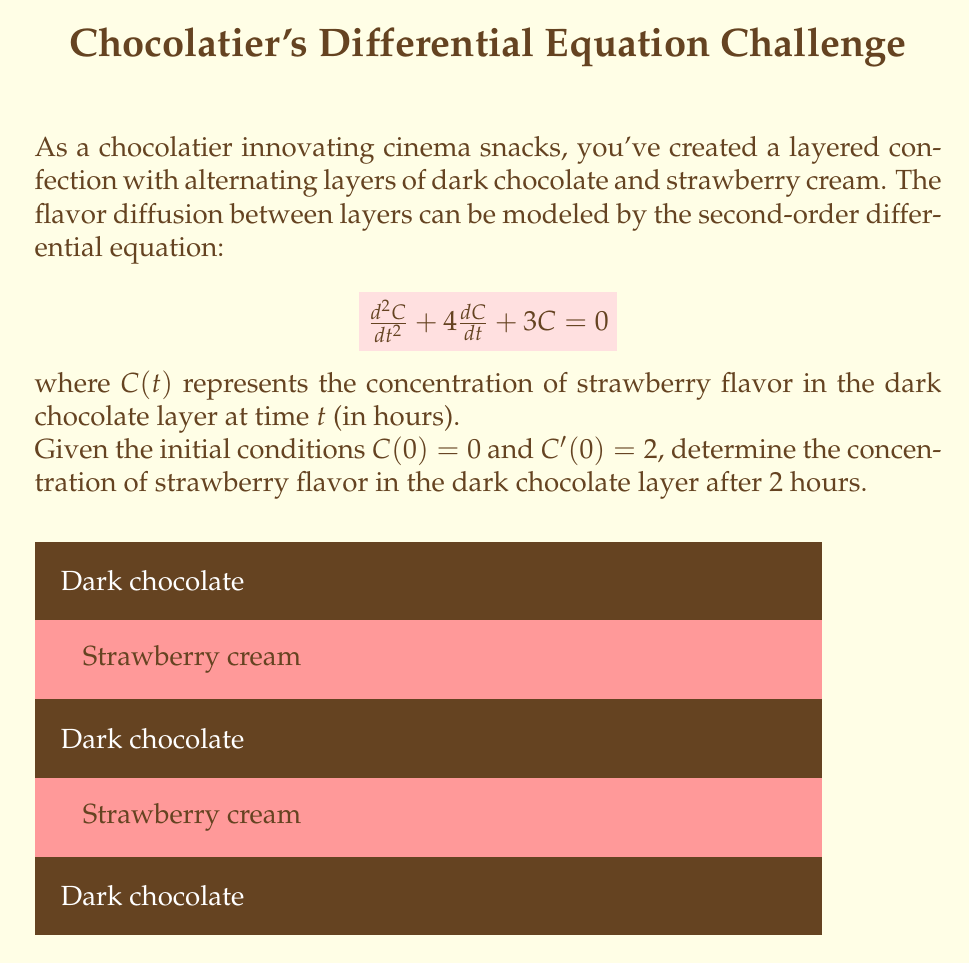Teach me how to tackle this problem. To solve this problem, we'll follow these steps:

1) The characteristic equation for the given differential equation is:
   $$r^2 + 4r + 3 = 0$$

2) Solving this quadratic equation:
   $$r = \frac{-4 \pm \sqrt{16 - 12}}{2} = \frac{-4 \pm 2}{2}$$
   $$r_1 = -1, r_2 = -3$$

3) The general solution is therefore:
   $$C(t) = A e^{-t} + B e^{-3t}$$

4) Using the initial condition $C(0) = 0$:
   $$0 = A + B$$
   $$B = -A$$

5) The derivative of the general solution is:
   $$C'(t) = -A e^{-t} - 3B e^{-3t}$$

6) Using the initial condition $C'(0) = 2$:
   $$2 = -A - 3B = -A - 3(-A) = 2A$$
   $$A = 1, B = -1$$

7) Therefore, the particular solution is:
   $$C(t) = e^{-t} - e^{-3t}$$

8) To find the concentration after 2 hours, we evaluate $C(2)$:
   $$C(2) = e^{-2} - e^{-6}$$

9) Calculating this value:
   $$C(2) = 0.1353 - 0.0025 = 0.1328$$

Thus, the concentration of strawberry flavor in the dark chocolate layer after 2 hours is approximately 0.1328 units.
Answer: 0.1328 units 